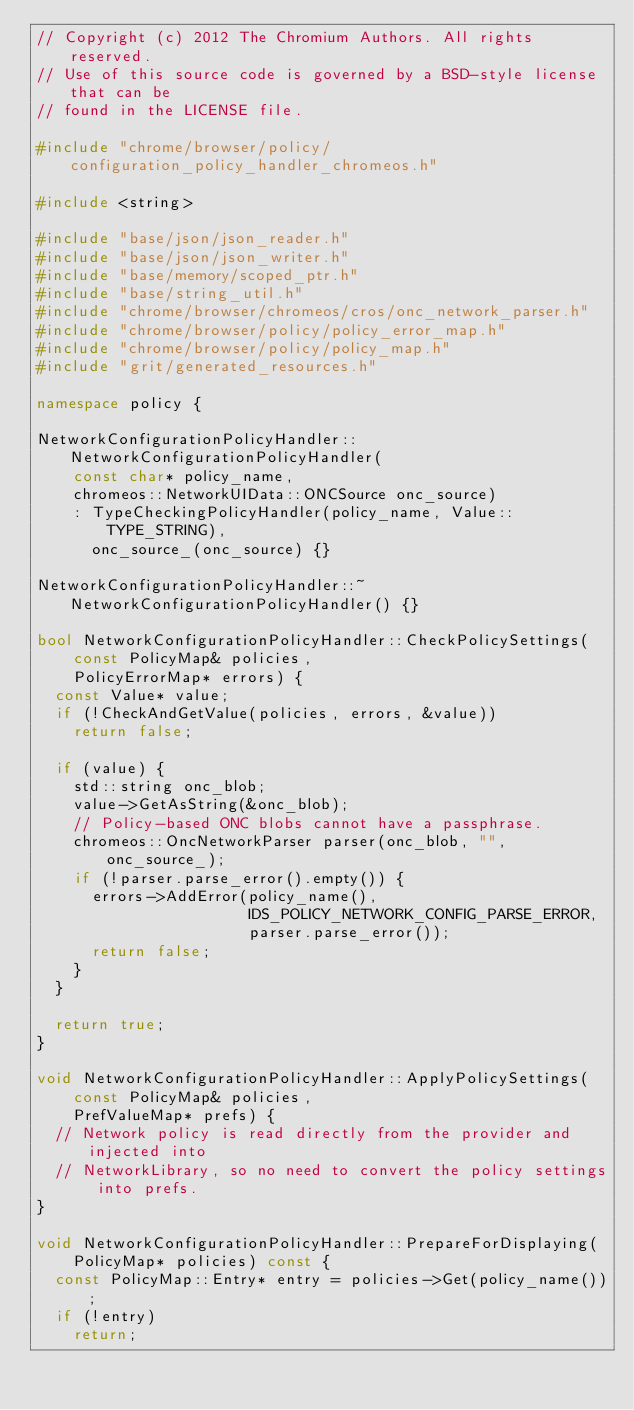<code> <loc_0><loc_0><loc_500><loc_500><_C++_>// Copyright (c) 2012 The Chromium Authors. All rights reserved.
// Use of this source code is governed by a BSD-style license that can be
// found in the LICENSE file.

#include "chrome/browser/policy/configuration_policy_handler_chromeos.h"

#include <string>

#include "base/json/json_reader.h"
#include "base/json/json_writer.h"
#include "base/memory/scoped_ptr.h"
#include "base/string_util.h"
#include "chrome/browser/chromeos/cros/onc_network_parser.h"
#include "chrome/browser/policy/policy_error_map.h"
#include "chrome/browser/policy/policy_map.h"
#include "grit/generated_resources.h"

namespace policy {

NetworkConfigurationPolicyHandler::NetworkConfigurationPolicyHandler(
    const char* policy_name,
    chromeos::NetworkUIData::ONCSource onc_source)
    : TypeCheckingPolicyHandler(policy_name, Value::TYPE_STRING),
      onc_source_(onc_source) {}

NetworkConfigurationPolicyHandler::~NetworkConfigurationPolicyHandler() {}

bool NetworkConfigurationPolicyHandler::CheckPolicySettings(
    const PolicyMap& policies,
    PolicyErrorMap* errors) {
  const Value* value;
  if (!CheckAndGetValue(policies, errors, &value))
    return false;

  if (value) {
    std::string onc_blob;
    value->GetAsString(&onc_blob);
    // Policy-based ONC blobs cannot have a passphrase.
    chromeos::OncNetworkParser parser(onc_blob, "", onc_source_);
    if (!parser.parse_error().empty()) {
      errors->AddError(policy_name(),
                       IDS_POLICY_NETWORK_CONFIG_PARSE_ERROR,
                       parser.parse_error());
      return false;
    }
  }

  return true;
}

void NetworkConfigurationPolicyHandler::ApplyPolicySettings(
    const PolicyMap& policies,
    PrefValueMap* prefs) {
  // Network policy is read directly from the provider and injected into
  // NetworkLibrary, so no need to convert the policy settings into prefs.
}

void NetworkConfigurationPolicyHandler::PrepareForDisplaying(
    PolicyMap* policies) const {
  const PolicyMap::Entry* entry = policies->Get(policy_name());
  if (!entry)
    return;</code> 